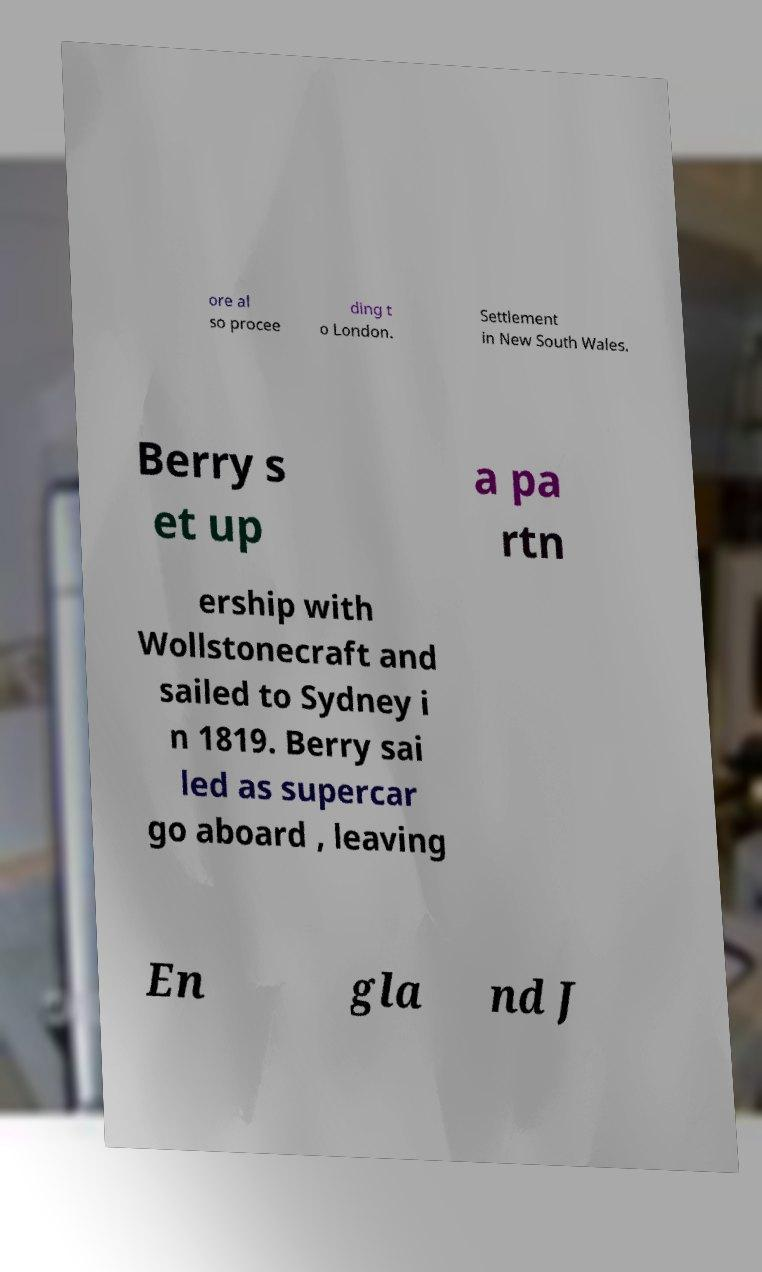Can you read and provide the text displayed in the image?This photo seems to have some interesting text. Can you extract and type it out for me? ore al so procee ding t o London. Settlement in New South Wales. Berry s et up a pa rtn ership with Wollstonecraft and sailed to Sydney i n 1819. Berry sai led as supercar go aboard , leaving En gla nd J 